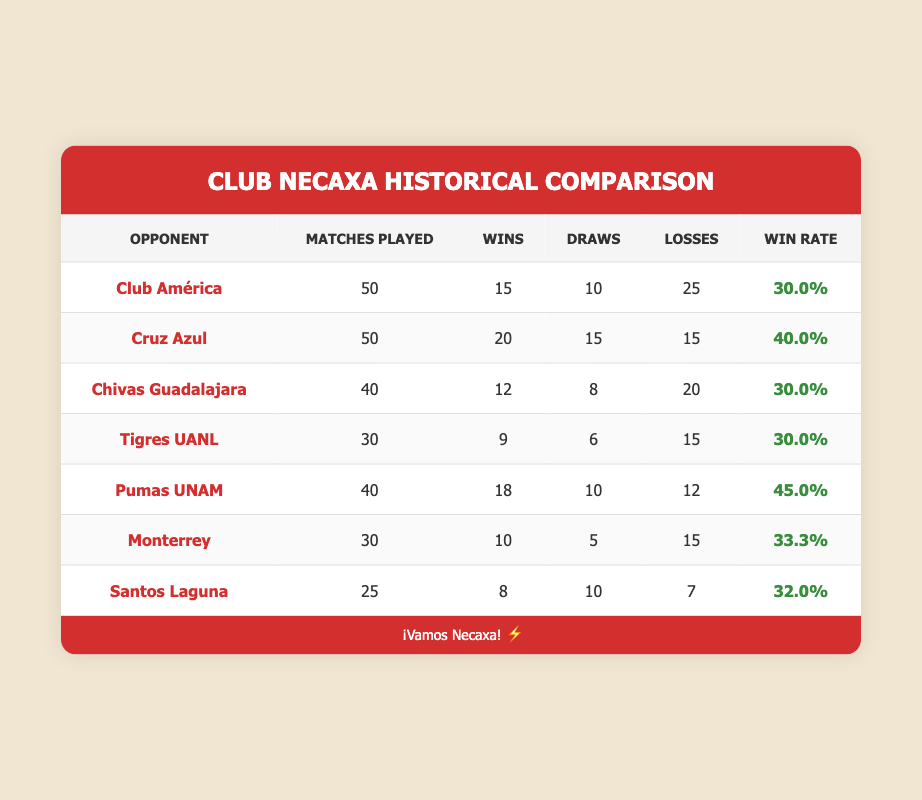What is Club Necaxa's win rate against Pumas UNAM? The win rate against Pumas UNAM is clearly listed in the table as 45.0%.
Answer: 45.0% How many matches did Club Necaxa play against Monterrey? The table specifies that Club Necaxa played 30 matches against Monterrey.
Answer: 30 Which opponent has the highest win rate against Club Necaxa? By comparing the win rates for all opponents, Pumas UNAM has the highest win rate at 45.0%.
Answer: Pumas UNAM What is the total number of matches played against Chivas Guadalajara and Tigres UANL? The total is calculated by adding the matches played against each: 40 (Chivas) + 30 (Tigres) = 70 matches total.
Answer: 70 Is it true that Club Necaxa has won more matches against Cruz Azul than any other opponent? This statement is false because Club Necaxa has won 20 matches against Cruz Azul, while they have won 18 against Pumas UNAM, which is close but still lower.
Answer: No What is the average win rate of Club Necaxa against their listed opponents? To find the average win rate, add all the win rates (30.0 + 40.0 + 30.0 + 30.0 + 45.0 + 33.3 + 32.0 = 240.3) and divide by the number of opponents (7), resulting in an average win rate of about 34.3%.
Answer: 34.3% How many losses did Club Necaxa incur against Santos Laguna? The table shows that Club Necaxa lost 7 times to Santos Laguna.
Answer: 7 Which opponent has the most draws against Club Necaxa? Cruz Azul has the most draws as per the table with 15 draws.
Answer: Cruz Azul What is the difference in win rates between Club América and Monterrey? The win rate for Club América is 30.0% and for Monterrey, it is 33.3%. The difference is calculated as 33.3 - 30.0 = 3.3%.
Answer: 3.3% 